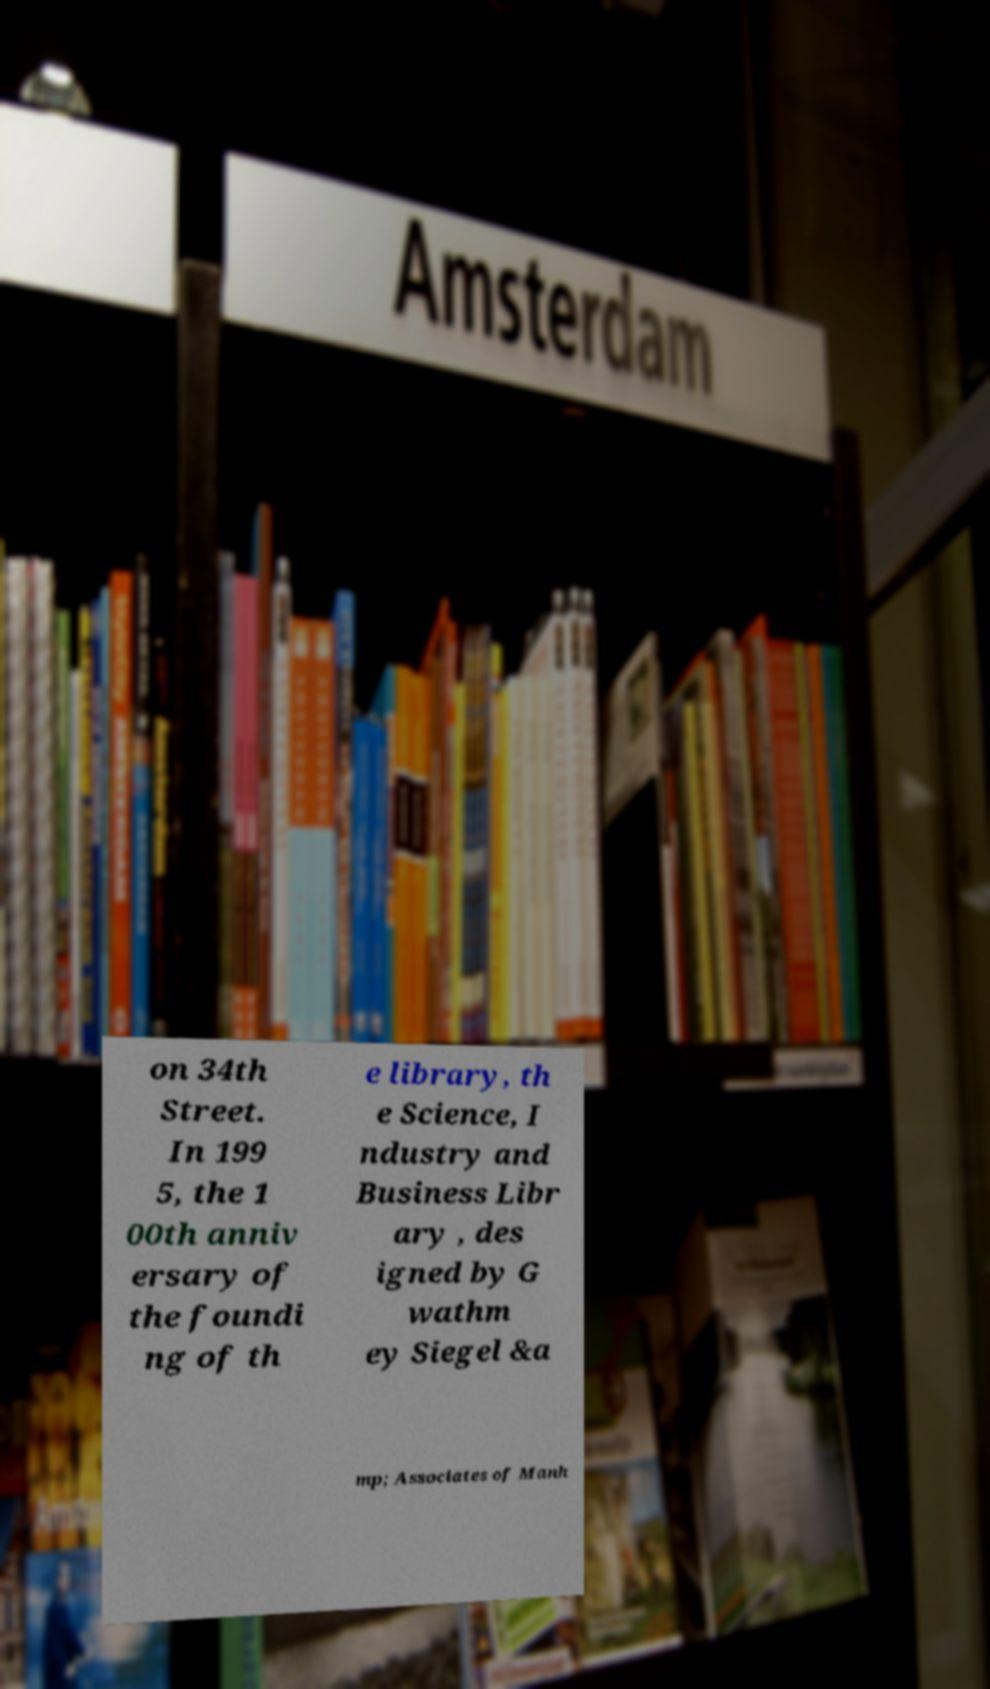Could you extract and type out the text from this image? on 34th Street. In 199 5, the 1 00th anniv ersary of the foundi ng of th e library, th e Science, I ndustry and Business Libr ary , des igned by G wathm ey Siegel &a mp; Associates of Manh 